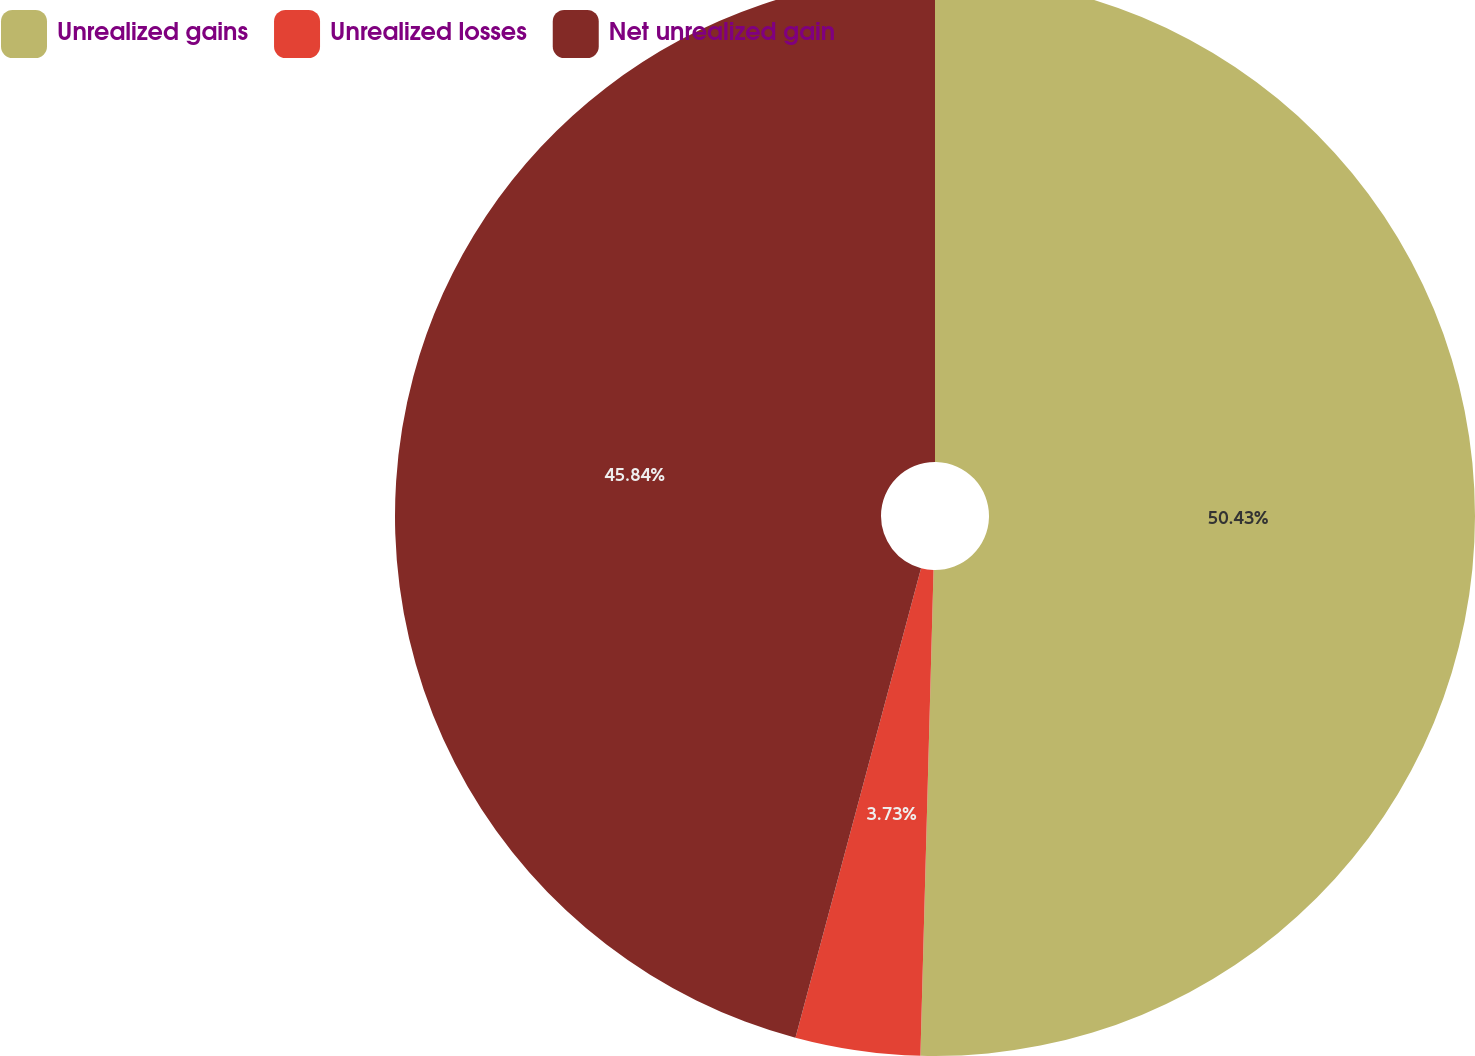<chart> <loc_0><loc_0><loc_500><loc_500><pie_chart><fcel>Unrealized gains<fcel>Unrealized losses<fcel>Net unrealized gain<nl><fcel>50.43%<fcel>3.73%<fcel>45.84%<nl></chart> 